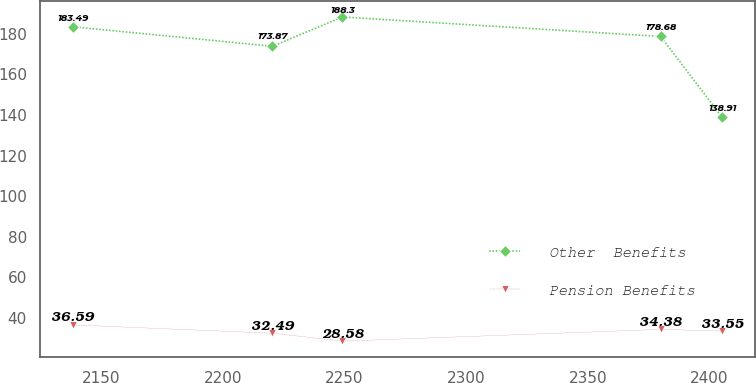Convert chart. <chart><loc_0><loc_0><loc_500><loc_500><line_chart><ecel><fcel>Other  Benefits<fcel>Pension Benefits<nl><fcel>2138.23<fcel>183.49<fcel>36.59<nl><fcel>2220.36<fcel>173.87<fcel>32.49<nl><fcel>2249.13<fcel>188.3<fcel>28.58<nl><fcel>2379.92<fcel>178.68<fcel>34.38<nl><fcel>2405.12<fcel>138.91<fcel>33.55<nl></chart> 